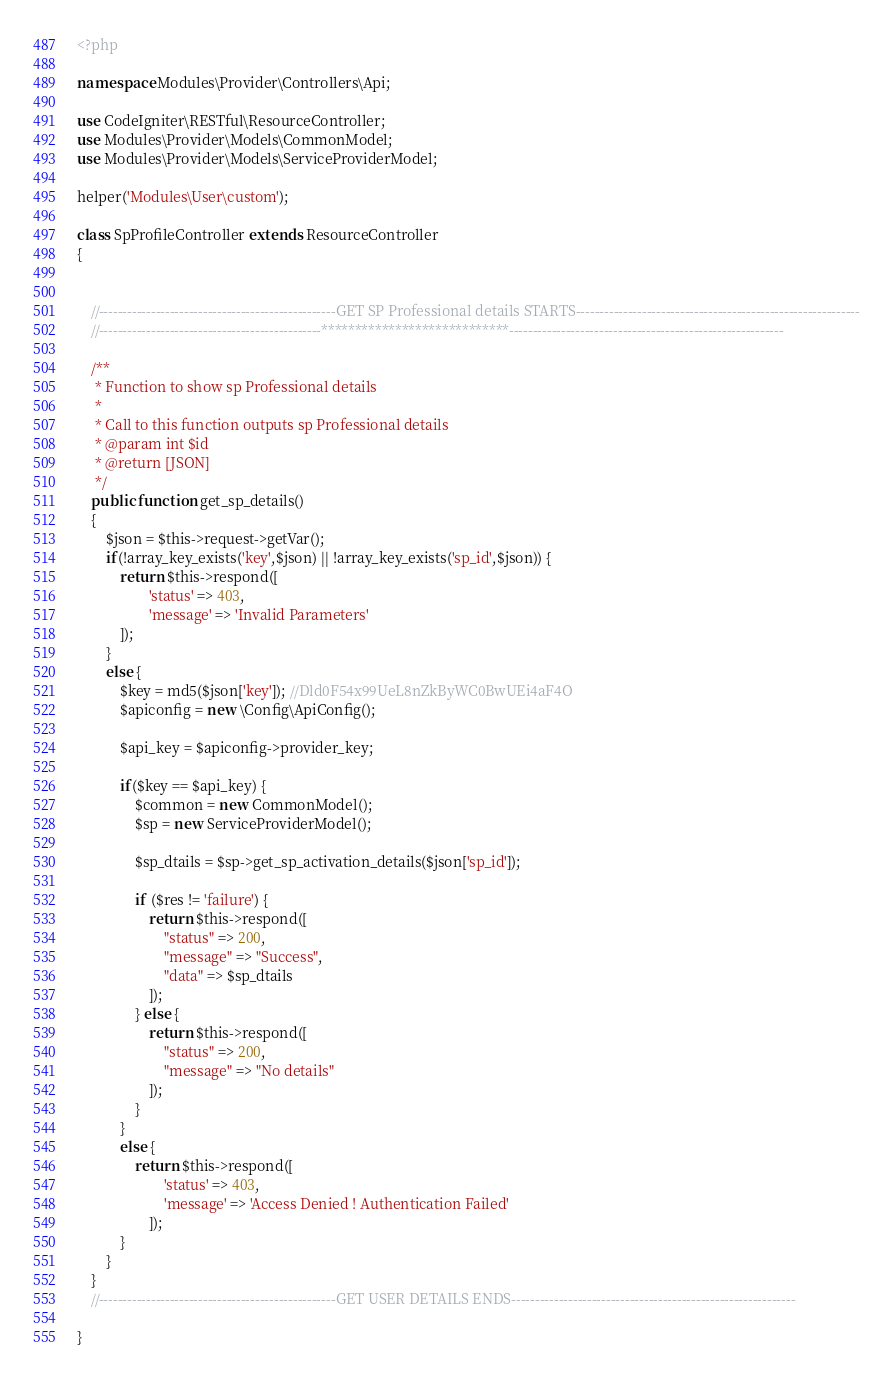Convert code to text. <code><loc_0><loc_0><loc_500><loc_500><_PHP_><?php

namespace Modules\Provider\Controllers\Api;

use CodeIgniter\RESTful\ResourceController;
use Modules\Provider\Models\CommonModel;
use Modules\Provider\Models\ServiceProviderModel;

helper('Modules\User\custom');

class SpProfileController extends ResourceController
{


    //--------------------------------------------------GET SP Professional details STARTS------------------------------------------------------------
    //-----------------------------------------------****************************----------------------------------------------------------

    /**
     * Function to show sp Professional details
     * 
     * Call to this function outputs sp Professional details
     * @param int $id
     * @return [JSON]
     */
    public function get_sp_details()
	{
		$json = $this->request->getVar();
		if(!array_key_exists('key',$json) || !array_key_exists('sp_id',$json)) {
		    return $this->respond([
    				'status' => 403,
                    'message' => 'Invalid Parameters'
    		]);
		}
		else {
		    $key = md5($json['key']); //Dld0F54x99UeL8nZkByWC0BwUEi4aF4O
		    $apiconfig = new \Config\ApiConfig();
		    
    		$api_key = $apiconfig->provider_key;
    		
    		if($key == $api_key) {
    		    $common = new CommonModel();
    		    $sp = new ServiceProviderModel();
    		    
        		$sp_dtails = $sp->get_sp_activation_details($json['sp_id']);
        
        		if ($res != 'failure') {
        			return $this->respond([
        				"status" => 200,
        				"message" => "Success",
        				"data" => $sp_dtails
        			]);
        		} else {
        			return $this->respond([
        				"status" => 200,
        				"message" => "No details"
        			]);
        		}
    		}
    		else {
    		    return $this->respond([
        				'status' => 403,
                        'message' => 'Access Denied ! Authentication Failed'
        			]);
    		}
		}
	}
    //--------------------------------------------------GET USER DETAILS ENDS------------------------------------------------------------

}
</code> 